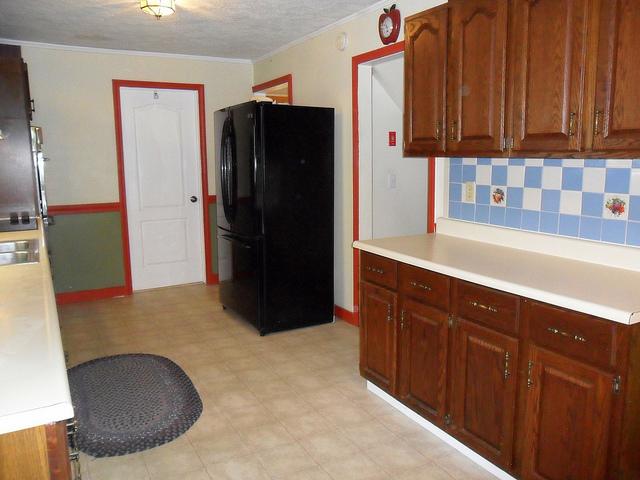Is the decor brand new or older?
Answer briefly. Older. What color is the refrigerator?
Short answer required. Black. What room is this?
Short answer required. Kitchen. 